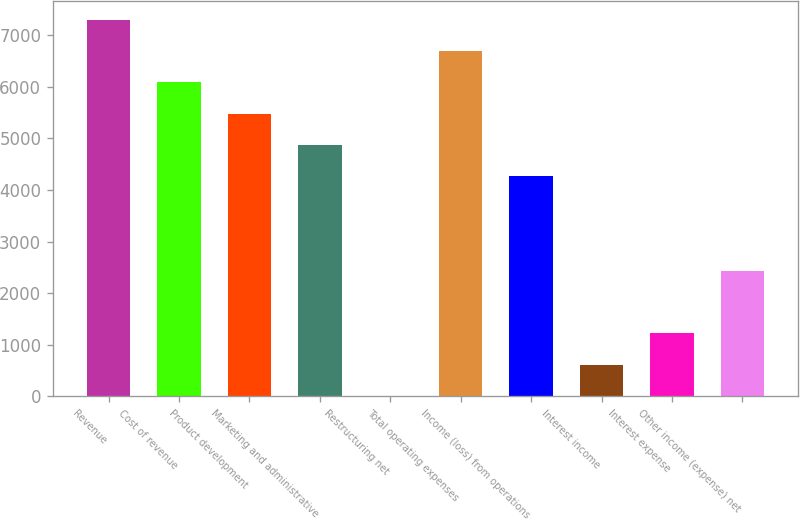<chart> <loc_0><loc_0><loc_500><loc_500><bar_chart><fcel>Revenue<fcel>Cost of revenue<fcel>Product development<fcel>Marketing and administrative<fcel>Restructuring net<fcel>Total operating expenses<fcel>Income (loss) from operations<fcel>Interest income<fcel>Interest expense<fcel>Other income (expense) net<nl><fcel>7303.6<fcel>6087<fcel>5478.7<fcel>4870.4<fcel>4<fcel>6695.3<fcel>4262.1<fcel>612.3<fcel>1220.6<fcel>2437.2<nl></chart> 